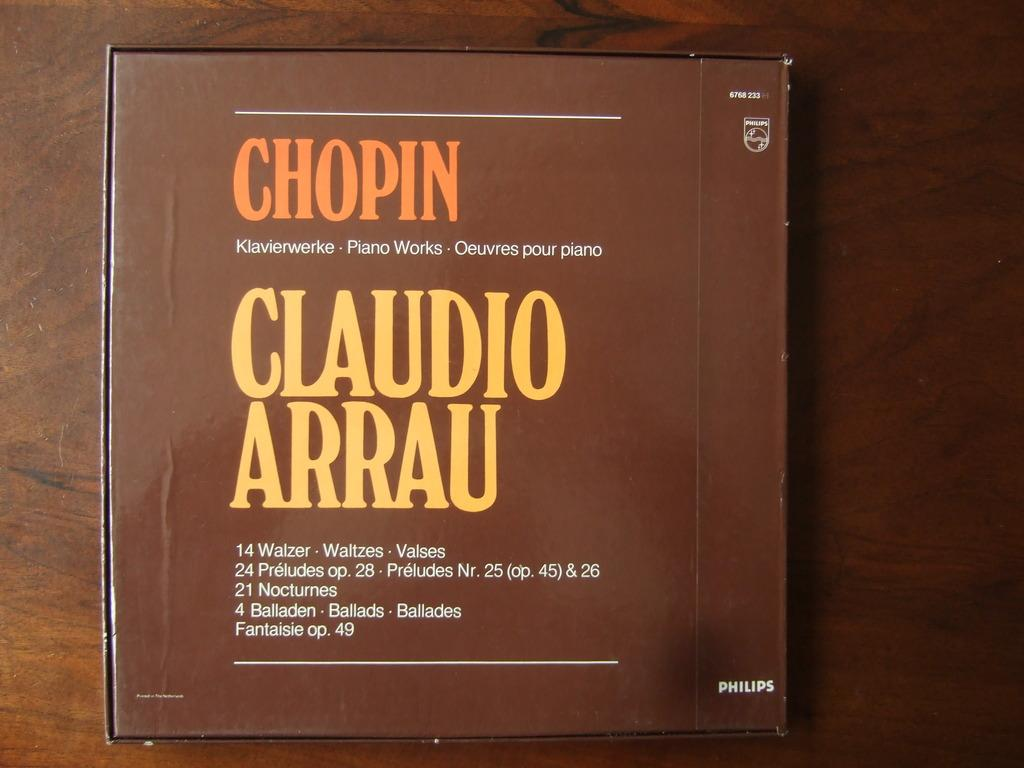<image>
Summarize the visual content of the image. A box, made by Philips corporation, hold the music of Chopin. 